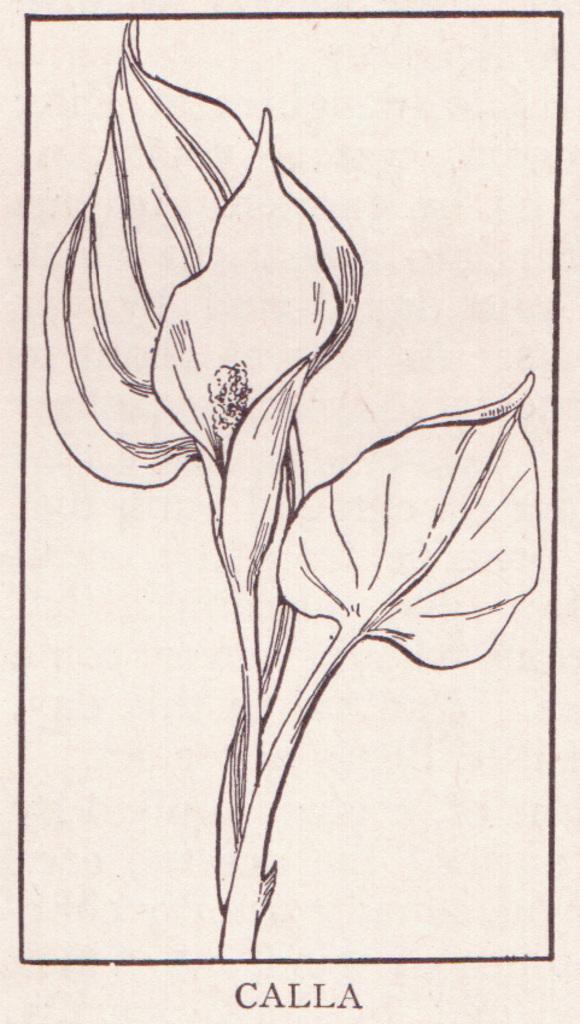In one or two sentences, can you explain what this image depicts? In this image we can see sketch of leaves and stem. There is some text at the bottom of the image. 